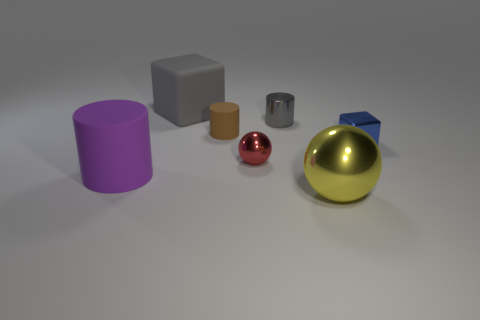The other tiny object that is the same shape as the small brown thing is what color?
Give a very brief answer. Gray. Are there any small metallic cylinders that have the same color as the big sphere?
Offer a very short reply. No. There is a block that is the same material as the red object; what size is it?
Your answer should be compact. Small. Is there anything else that has the same color as the large cube?
Provide a succinct answer. Yes. What is the color of the ball that is behind the yellow thing?
Keep it short and to the point. Red. There is a matte cylinder on the right side of the matte cylinder in front of the red object; are there any small brown things that are to the left of it?
Your answer should be very brief. No. Is the number of metallic balls that are left of the large yellow metal ball greater than the number of small blue metal objects?
Give a very brief answer. No. There is a large rubber thing that is behind the big purple matte object; is its shape the same as the tiny red metallic thing?
Provide a succinct answer. No. Are there any other things that have the same material as the large cube?
Provide a short and direct response. Yes. What number of things are either large purple cylinders or objects behind the tiny brown object?
Make the answer very short. 3. 